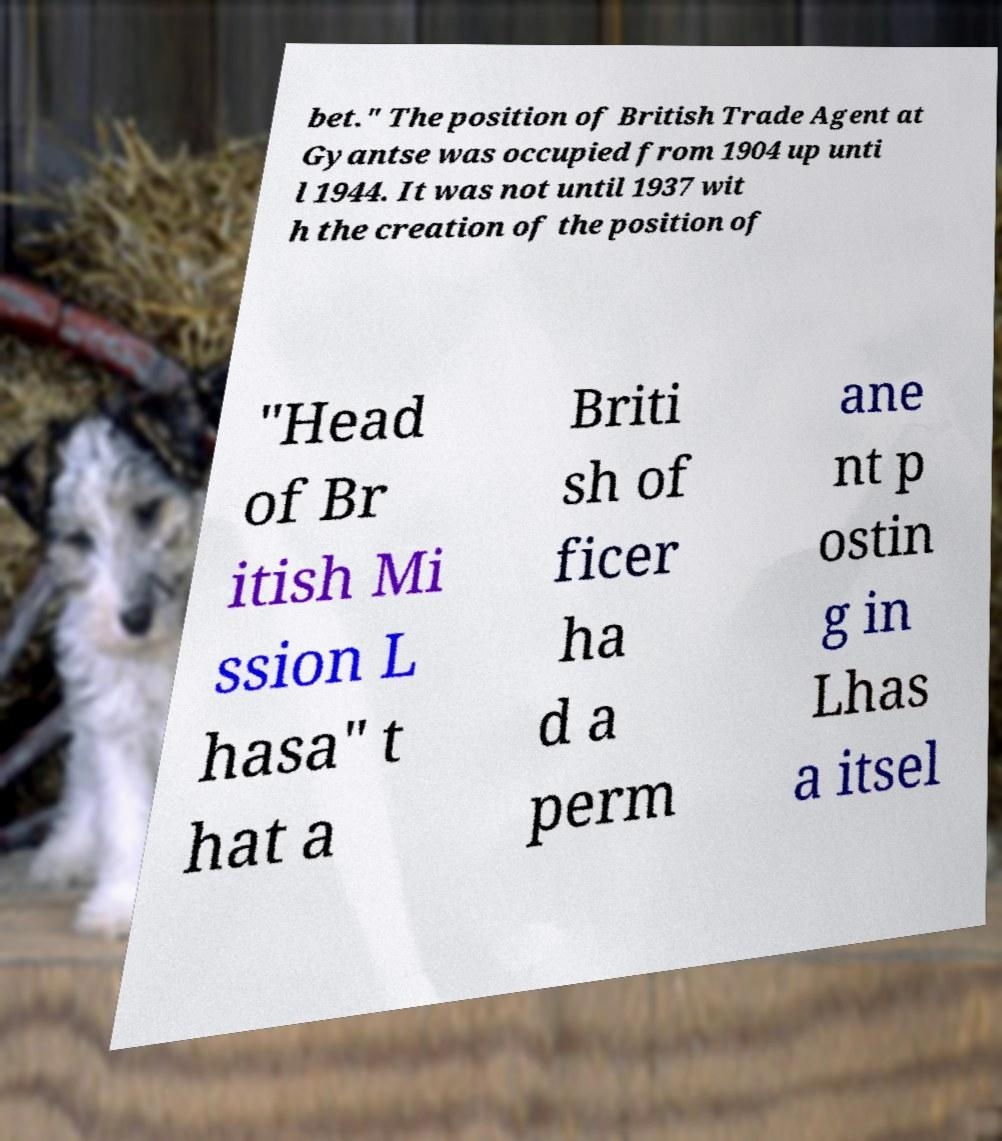Please read and relay the text visible in this image. What does it say? bet." The position of British Trade Agent at Gyantse was occupied from 1904 up unti l 1944. It was not until 1937 wit h the creation of the position of "Head of Br itish Mi ssion L hasa" t hat a Briti sh of ficer ha d a perm ane nt p ostin g in Lhas a itsel 